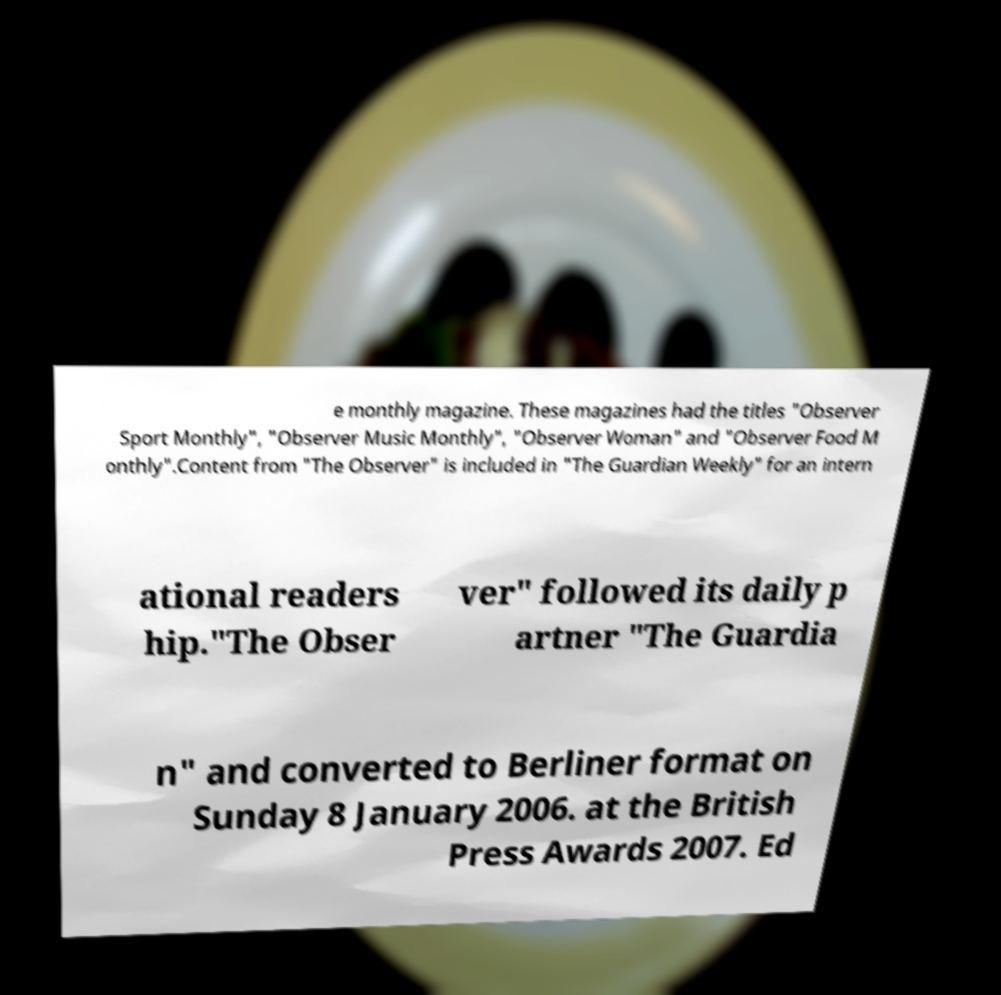I need the written content from this picture converted into text. Can you do that? e monthly magazine. These magazines had the titles "Observer Sport Monthly", "Observer Music Monthly", "Observer Woman" and "Observer Food M onthly".Content from "The Observer" is included in "The Guardian Weekly" for an intern ational readers hip."The Obser ver" followed its daily p artner "The Guardia n" and converted to Berliner format on Sunday 8 January 2006. at the British Press Awards 2007. Ed 